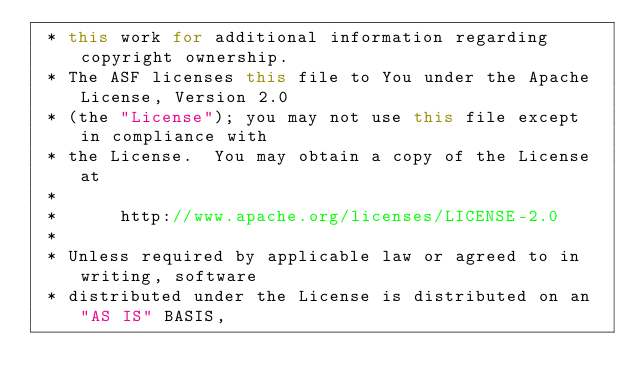Convert code to text. <code><loc_0><loc_0><loc_500><loc_500><_Java_> * this work for additional information regarding copyright ownership.
 * The ASF licenses this file to You under the Apache License, Version 2.0
 * (the "License"); you may not use this file except in compliance with
 * the License.  You may obtain a copy of the License at
 *
 *      http://www.apache.org/licenses/LICENSE-2.0
 *
 * Unless required by applicable law or agreed to in writing, software
 * distributed under the License is distributed on an "AS IS" BASIS,</code> 